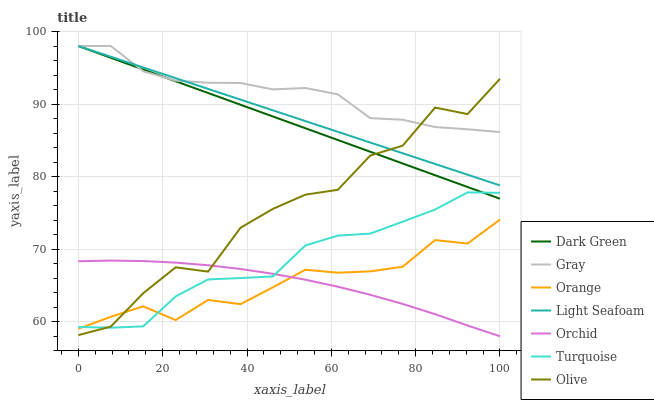Does Orchid have the minimum area under the curve?
Answer yes or no. Yes. Does Gray have the maximum area under the curve?
Answer yes or no. Yes. Does Turquoise have the minimum area under the curve?
Answer yes or no. No. Does Turquoise have the maximum area under the curve?
Answer yes or no. No. Is Light Seafoam the smoothest?
Answer yes or no. Yes. Is Olive the roughest?
Answer yes or no. Yes. Is Turquoise the smoothest?
Answer yes or no. No. Is Turquoise the roughest?
Answer yes or no. No. Does Turquoise have the lowest value?
Answer yes or no. No. Does Light Seafoam have the highest value?
Answer yes or no. Yes. Does Turquoise have the highest value?
Answer yes or no. No. Is Orchid less than Light Seafoam?
Answer yes or no. Yes. Is Gray greater than Orange?
Answer yes or no. Yes. Does Orchid intersect Light Seafoam?
Answer yes or no. No. 